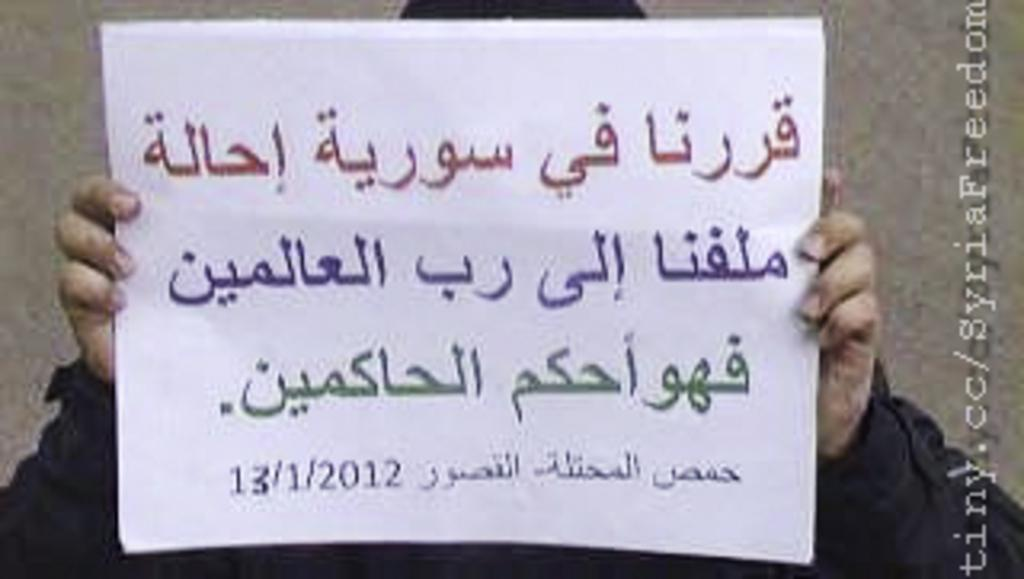<image>
Present a compact description of the photo's key features. A man is holding a sheet of paper with Arabic letters on it and the date 13/1/2012. 